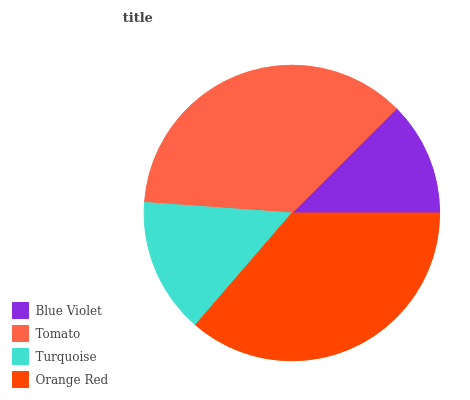Is Blue Violet the minimum?
Answer yes or no. Yes. Is Tomato the maximum?
Answer yes or no. Yes. Is Turquoise the minimum?
Answer yes or no. No. Is Turquoise the maximum?
Answer yes or no. No. Is Tomato greater than Turquoise?
Answer yes or no. Yes. Is Turquoise less than Tomato?
Answer yes or no. Yes. Is Turquoise greater than Tomato?
Answer yes or no. No. Is Tomato less than Turquoise?
Answer yes or no. No. Is Orange Red the high median?
Answer yes or no. Yes. Is Turquoise the low median?
Answer yes or no. Yes. Is Blue Violet the high median?
Answer yes or no. No. Is Tomato the low median?
Answer yes or no. No. 